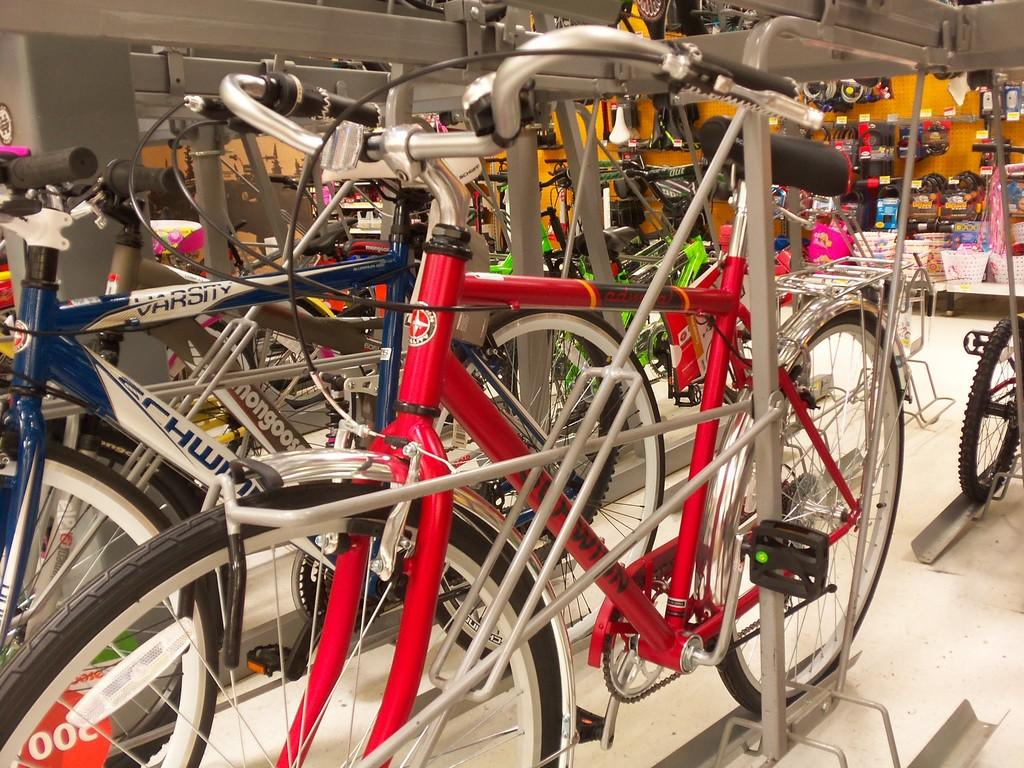What is the location of the scene in the image? The image is set in a store. What type of products can be seen in the store? There are plenty of cycles in the store. Are there any other items on display in the store? Yes, other items are on display in the store. How many times do the eyes of the cycles blink in the image? There are no eyes on the cycles in the image, as cycles do not have eyes. 